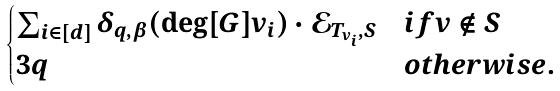Convert formula to latex. <formula><loc_0><loc_0><loc_500><loc_500>\begin{cases} \sum _ { i \in [ d ] } \delta _ { q , \beta } ( \deg [ G ] { v _ { i } } ) \cdot \mathcal { E } _ { T _ { v _ { i } } , S } & i f v \not \in S \\ 3 q & o t h e r w i s e . \end{cases}</formula> 